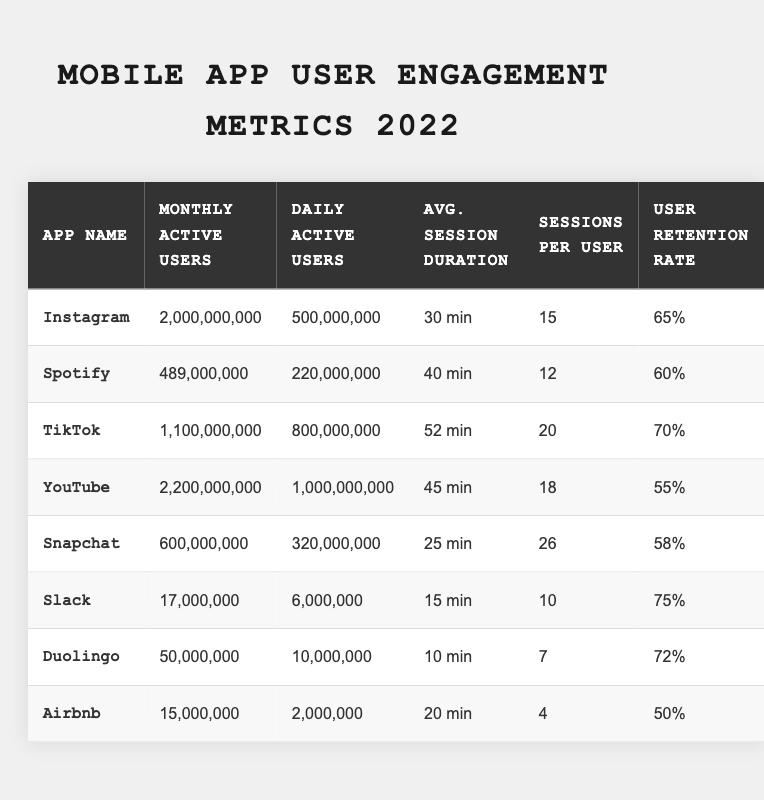What is the app with the highest number of monthly active users? By reviewing the table, I see that Instagram has 2,000,000,000 monthly active users, which is higher than the others listed.
Answer: Instagram How many daily active users does TikTok have? Looking at the table, TikTok has 800,000,000 daily active users listed.
Answer: 800,000,000 What is the average session duration for Snapchat? In the table, Snapchat's average session duration is mentioned as 25 minutes.
Answer: 25 min Which app has the highest user retention rate? According to the table, Slack has the highest user retention rate at 75%.
Answer: Slack What are the average session durations for YouTube and Spotify combined? The average session duration for YouTube is 45 minutes and for Spotify is 40 minutes. Adding them gives 45 + 40 = 85 minutes. Then, dividing by 2 for the average gives 85/2 = 42.5 minutes.
Answer: 42.5 min Is Duolingo's user retention rate above 70%? The retention rate for Duolingo is 72%, which is higher than 70%. Therefore, the statement is true.
Answer: Yes What is the difference in daily active users between YouTube and Instagram? YouTube has 1,000,000,000 daily active users, and Instagram has 500,000,000. The difference can be calculated as 1,000,000,000 - 500,000,000 = 500,000,000.
Answer: 500,000,000 Which app has the lowest number of monthly active users? By examining the table, I find that Airbnb has the lowest at 15,000,000 monthly active users.
Answer: Airbnb How many more sessions per user does Snapchat have compared to Duolingo? Snapchat has 26 sessions per user and Duolingo has 7. The difference is calculated as 26 - 7 = 19 sessions per user.
Answer: 19 What is the total number of monthly active users for all apps listed? To find the total, I sum the monthly active users: 2,000,000,000 + 489,000,000 + 1,100,000,000 + 2,200,000,000 + 600,000,000 + 17,000,000 + 50,000,000 + 15,000,000 = 6,471,000,000.
Answer: 6,471,000,000 